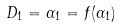<formula> <loc_0><loc_0><loc_500><loc_500>D _ { 1 } = \alpha _ { 1 } = f ( \alpha _ { 1 } )</formula> 